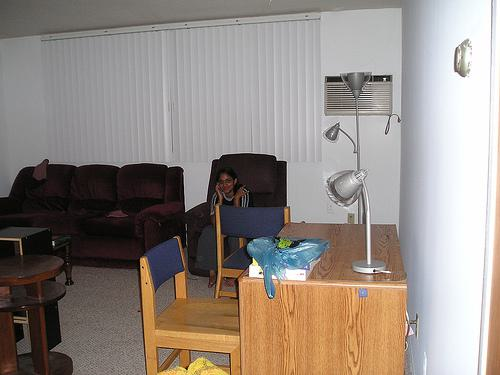Describe any personal items that make the space unique. Personal touches in the room include items like the floor lamp with adjustable arms, providing a sense of personal choice in lighting, and small objects on tables that may have sentimental value or serve practical purposes for the occupants. 